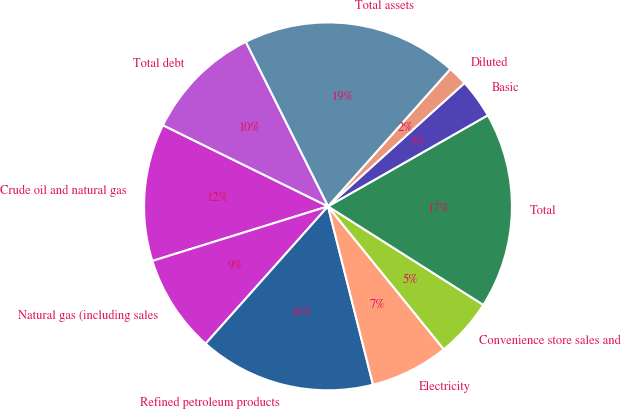Convert chart to OTSL. <chart><loc_0><loc_0><loc_500><loc_500><pie_chart><fcel>Crude oil and natural gas<fcel>Natural gas (including sales<fcel>Refined petroleum products<fcel>Electricity<fcel>Convenience store sales and<fcel>Total<fcel>Basic<fcel>Diluted<fcel>Total assets<fcel>Total debt<nl><fcel>12.07%<fcel>8.62%<fcel>15.52%<fcel>6.9%<fcel>5.17%<fcel>17.24%<fcel>3.45%<fcel>1.72%<fcel>18.97%<fcel>10.34%<nl></chart> 